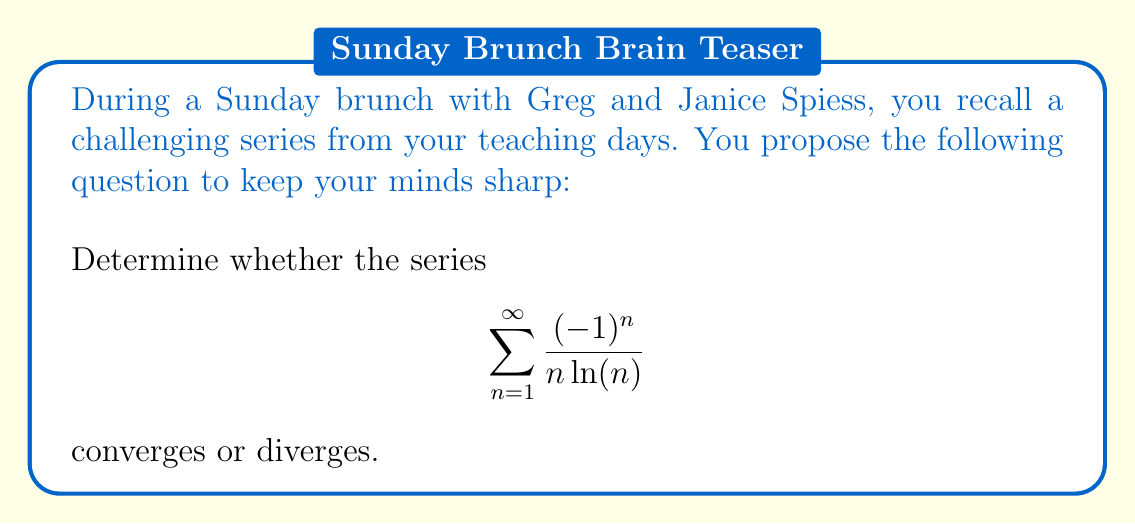Teach me how to tackle this problem. Let's approach this step-by-step using the alternating series test:

1) First, we need to check if the series satisfies the conditions for the alternating series test:

   a) The terms alternate in sign: $(-1)^n$ ensures this.
   b) $|a_n| = |\frac{1}{n\ln(n)}|$ should decrease monotonically.
   c) $\lim_{n \to \infty} |a_n| = \lim_{n \to \infty} \frac{1}{n\ln(n)} = 0$

2) Let's verify condition (b):
   
   $f(x) = \frac{1}{x\ln(x)}$, $f'(x) = -\frac{1+\ln(x)}{x^2(\ln(x))^2}$
   
   For $x > e$, $f'(x) < 0$, so $f(x)$ is decreasing for $n > 3$.

3) For condition (c):
   
   $\lim_{n \to \infty} \frac{1}{n\ln(n)} = 0$ (by L'Hôpital's rule)

4) All conditions of the alternating series test are satisfied.

5) Therefore, the series converges.

Note: We can also observe that this series converges more slowly than the harmonic series $\sum \frac{1}{n}$, which diverges. This is because $\frac{1}{n\ln(n)} > \frac{1}{n}$ for large $n$.
Answer: The series converges. 